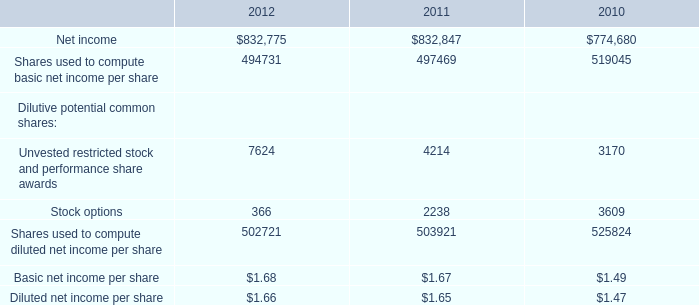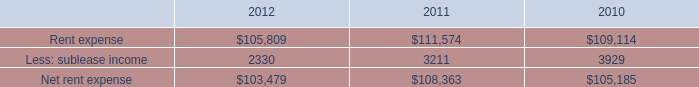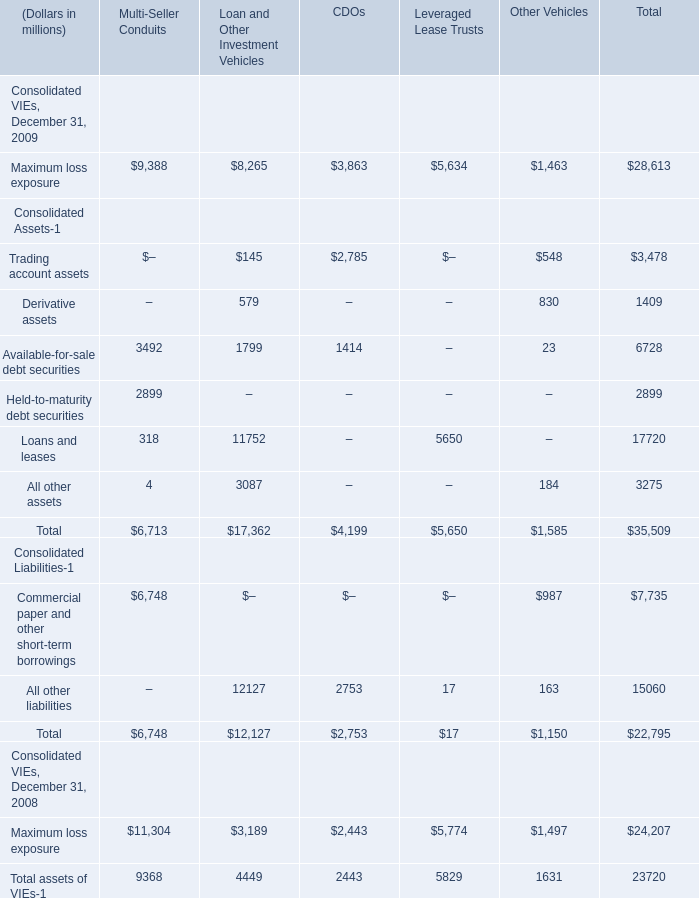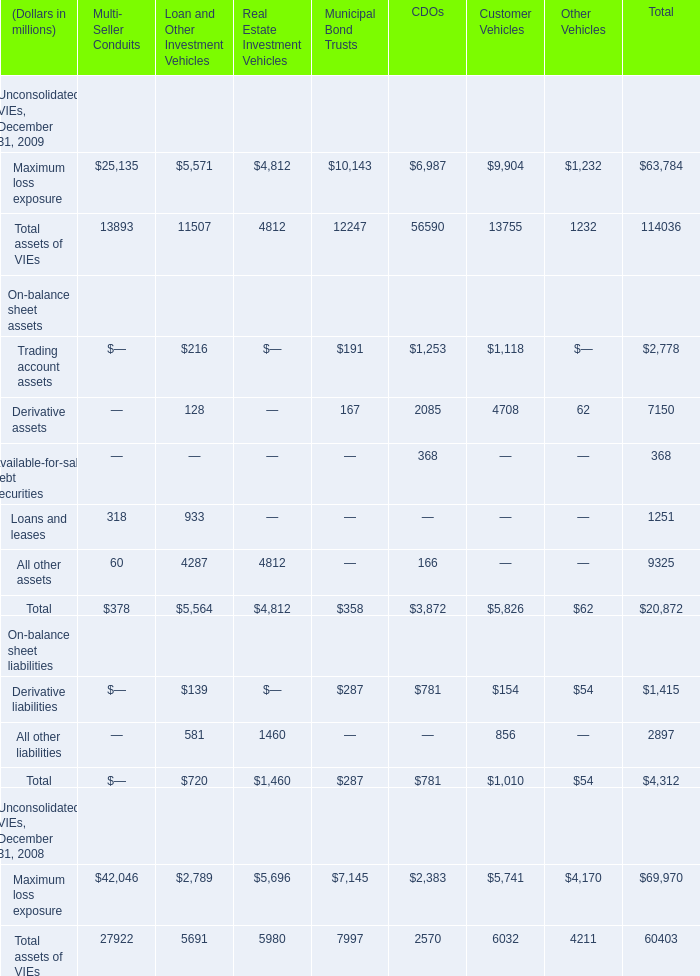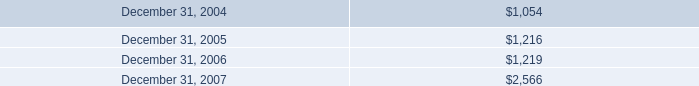what's the total amount of Maximum loss exposure of Municipal Bond Trusts, Rent expense of 2012, and Maximum loss exposure of Real Estate Investment Vehicles ? 
Computations: ((10143.0 + 105809.0) + 4812.0)
Answer: 120764.0. 